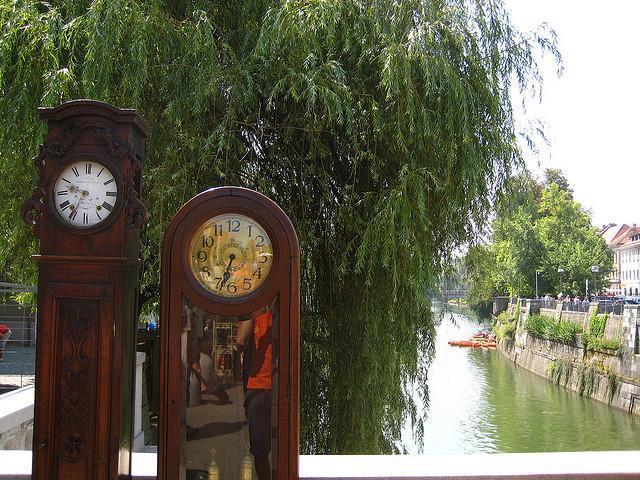How many people can be seen?
Give a very brief answer. 1. How many clocks are in the photo?
Give a very brief answer. 2. 